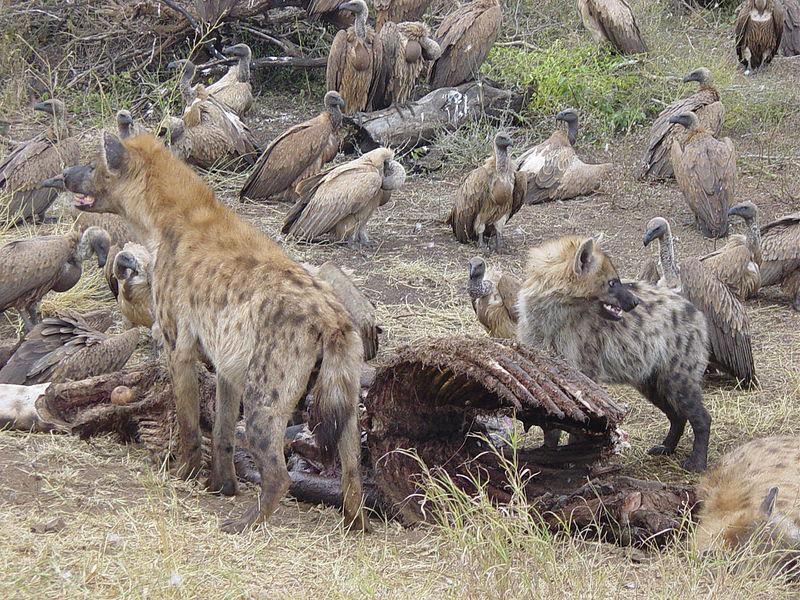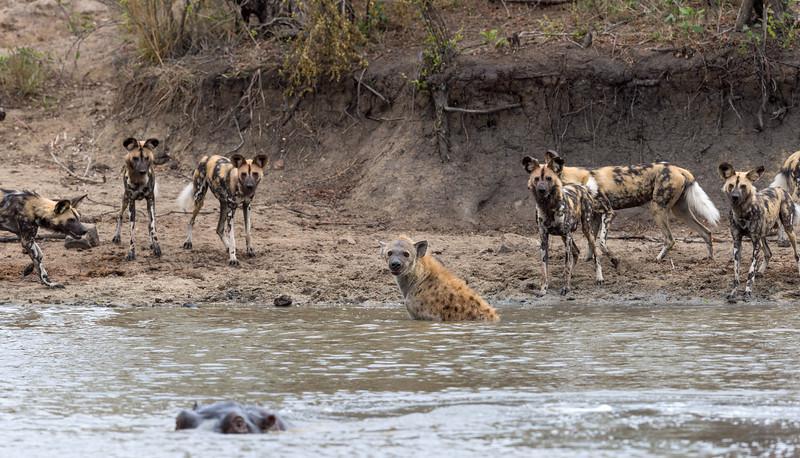The first image is the image on the left, the second image is the image on the right. Assess this claim about the two images: "An image shows at least six hyenas, with multicolored fur featuring blotches of color instead of spots, standing around a watering hole.". Correct or not? Answer yes or no. Yes. The first image is the image on the left, the second image is the image on the right. For the images shown, is this caption "There are at least six wild dogs are standing on the shore line." true? Answer yes or no. Yes. 